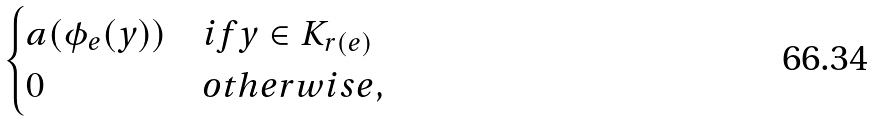<formula> <loc_0><loc_0><loc_500><loc_500>\begin{cases} a ( \phi _ { e } ( y ) ) & i f y \in K _ { r ( e ) } \\ 0 & o t h e r w i s e , \end{cases}</formula> 